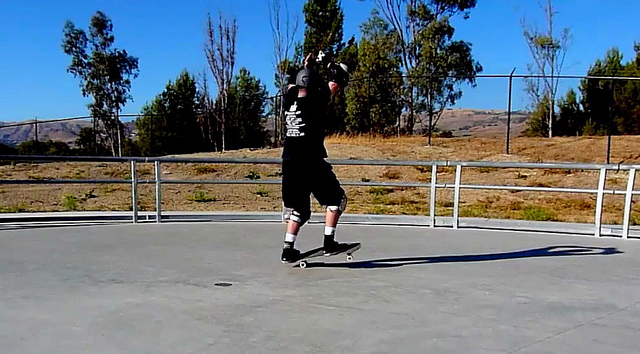What type of area is the man skateboarding in? The man is skateboarding in what looks like a skate park or an open concrete area. The presence of railings and the expansive, flat surface suggest this location is designed for activities like skateboarding, providing ample space for skaters to perform tricks. The surroundings, including trees and a scenic backdrop, add a natural element to the setting. 